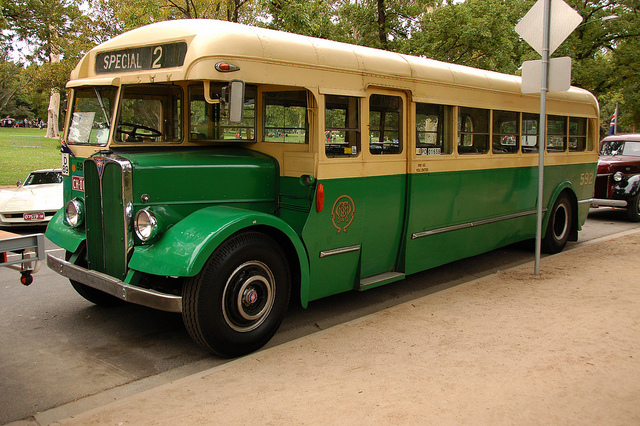Please extract the text content from this image. SPECIAL 2 53 